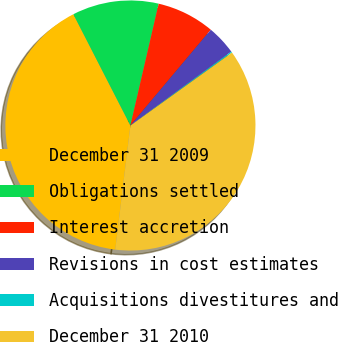Convert chart. <chart><loc_0><loc_0><loc_500><loc_500><pie_chart><fcel>December 31 2009<fcel>Obligations settled<fcel>Interest accretion<fcel>Revisions in cost estimates<fcel>Acquisitions divestitures and<fcel>December 31 2010<nl><fcel>40.53%<fcel>11.17%<fcel>7.49%<fcel>3.82%<fcel>0.15%<fcel>36.85%<nl></chart> 